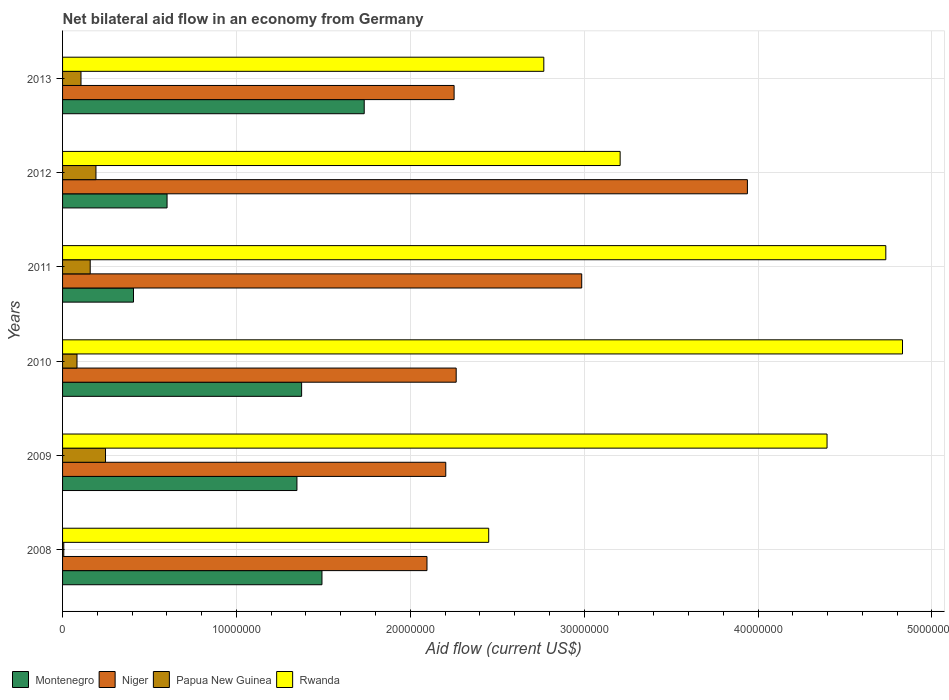How many different coloured bars are there?
Your answer should be compact. 4. Are the number of bars per tick equal to the number of legend labels?
Offer a terse response. Yes. How many bars are there on the 5th tick from the top?
Keep it short and to the point. 4. What is the label of the 6th group of bars from the top?
Make the answer very short. 2008. In how many cases, is the number of bars for a given year not equal to the number of legend labels?
Your answer should be compact. 0. What is the net bilateral aid flow in Niger in 2010?
Your answer should be very brief. 2.26e+07. Across all years, what is the maximum net bilateral aid flow in Papua New Guinea?
Provide a succinct answer. 2.47e+06. In which year was the net bilateral aid flow in Montenegro maximum?
Your answer should be very brief. 2013. In which year was the net bilateral aid flow in Niger minimum?
Make the answer very short. 2008. What is the total net bilateral aid flow in Niger in the graph?
Your answer should be compact. 1.57e+08. What is the difference between the net bilateral aid flow in Montenegro in 2008 and that in 2011?
Ensure brevity in your answer.  1.08e+07. What is the difference between the net bilateral aid flow in Montenegro in 2011 and the net bilateral aid flow in Papua New Guinea in 2008?
Your response must be concise. 4.01e+06. What is the average net bilateral aid flow in Niger per year?
Make the answer very short. 2.62e+07. In the year 2009, what is the difference between the net bilateral aid flow in Rwanda and net bilateral aid flow in Papua New Guinea?
Offer a terse response. 4.15e+07. In how many years, is the net bilateral aid flow in Papua New Guinea greater than 32000000 US$?
Your response must be concise. 0. What is the ratio of the net bilateral aid flow in Rwanda in 2008 to that in 2013?
Your response must be concise. 0.89. Is the net bilateral aid flow in Niger in 2011 less than that in 2012?
Your answer should be very brief. Yes. What is the difference between the highest and the second highest net bilateral aid flow in Niger?
Your answer should be compact. 9.53e+06. What is the difference between the highest and the lowest net bilateral aid flow in Rwanda?
Your response must be concise. 2.38e+07. What does the 2nd bar from the top in 2012 represents?
Your response must be concise. Papua New Guinea. What does the 3rd bar from the bottom in 2013 represents?
Offer a very short reply. Papua New Guinea. How many bars are there?
Give a very brief answer. 24. Are all the bars in the graph horizontal?
Ensure brevity in your answer.  Yes. How many years are there in the graph?
Ensure brevity in your answer.  6. Does the graph contain any zero values?
Provide a short and direct response. No. How many legend labels are there?
Make the answer very short. 4. What is the title of the graph?
Your answer should be compact. Net bilateral aid flow in an economy from Germany. What is the Aid flow (current US$) of Montenegro in 2008?
Offer a terse response. 1.49e+07. What is the Aid flow (current US$) in Niger in 2008?
Your answer should be compact. 2.10e+07. What is the Aid flow (current US$) in Papua New Guinea in 2008?
Provide a succinct answer. 7.00e+04. What is the Aid flow (current US$) of Rwanda in 2008?
Provide a succinct answer. 2.45e+07. What is the Aid flow (current US$) in Montenegro in 2009?
Your response must be concise. 1.35e+07. What is the Aid flow (current US$) of Niger in 2009?
Keep it short and to the point. 2.20e+07. What is the Aid flow (current US$) of Papua New Guinea in 2009?
Make the answer very short. 2.47e+06. What is the Aid flow (current US$) in Rwanda in 2009?
Your answer should be compact. 4.40e+07. What is the Aid flow (current US$) of Montenegro in 2010?
Offer a very short reply. 1.38e+07. What is the Aid flow (current US$) of Niger in 2010?
Offer a very short reply. 2.26e+07. What is the Aid flow (current US$) of Papua New Guinea in 2010?
Keep it short and to the point. 8.30e+05. What is the Aid flow (current US$) in Rwanda in 2010?
Give a very brief answer. 4.83e+07. What is the Aid flow (current US$) in Montenegro in 2011?
Offer a very short reply. 4.08e+06. What is the Aid flow (current US$) of Niger in 2011?
Your response must be concise. 2.99e+07. What is the Aid flow (current US$) in Papua New Guinea in 2011?
Give a very brief answer. 1.59e+06. What is the Aid flow (current US$) of Rwanda in 2011?
Keep it short and to the point. 4.74e+07. What is the Aid flow (current US$) in Montenegro in 2012?
Provide a short and direct response. 6.01e+06. What is the Aid flow (current US$) in Niger in 2012?
Ensure brevity in your answer.  3.94e+07. What is the Aid flow (current US$) in Papua New Guinea in 2012?
Offer a very short reply. 1.92e+06. What is the Aid flow (current US$) of Rwanda in 2012?
Give a very brief answer. 3.21e+07. What is the Aid flow (current US$) of Montenegro in 2013?
Provide a short and direct response. 1.74e+07. What is the Aid flow (current US$) of Niger in 2013?
Keep it short and to the point. 2.25e+07. What is the Aid flow (current US$) in Papua New Guinea in 2013?
Your answer should be compact. 1.06e+06. What is the Aid flow (current US$) of Rwanda in 2013?
Keep it short and to the point. 2.77e+07. Across all years, what is the maximum Aid flow (current US$) of Montenegro?
Give a very brief answer. 1.74e+07. Across all years, what is the maximum Aid flow (current US$) of Niger?
Offer a very short reply. 3.94e+07. Across all years, what is the maximum Aid flow (current US$) in Papua New Guinea?
Your answer should be very brief. 2.47e+06. Across all years, what is the maximum Aid flow (current US$) of Rwanda?
Your answer should be very brief. 4.83e+07. Across all years, what is the minimum Aid flow (current US$) of Montenegro?
Keep it short and to the point. 4.08e+06. Across all years, what is the minimum Aid flow (current US$) in Niger?
Your answer should be compact. 2.10e+07. Across all years, what is the minimum Aid flow (current US$) in Papua New Guinea?
Make the answer very short. 7.00e+04. Across all years, what is the minimum Aid flow (current US$) of Rwanda?
Give a very brief answer. 2.45e+07. What is the total Aid flow (current US$) in Montenegro in the graph?
Provide a succinct answer. 6.96e+07. What is the total Aid flow (current US$) in Niger in the graph?
Offer a terse response. 1.57e+08. What is the total Aid flow (current US$) of Papua New Guinea in the graph?
Your response must be concise. 7.94e+06. What is the total Aid flow (current US$) in Rwanda in the graph?
Your response must be concise. 2.24e+08. What is the difference between the Aid flow (current US$) of Montenegro in 2008 and that in 2009?
Provide a short and direct response. 1.44e+06. What is the difference between the Aid flow (current US$) of Niger in 2008 and that in 2009?
Give a very brief answer. -1.08e+06. What is the difference between the Aid flow (current US$) of Papua New Guinea in 2008 and that in 2009?
Your response must be concise. -2.40e+06. What is the difference between the Aid flow (current US$) of Rwanda in 2008 and that in 2009?
Offer a terse response. -1.95e+07. What is the difference between the Aid flow (current US$) of Montenegro in 2008 and that in 2010?
Ensure brevity in your answer.  1.17e+06. What is the difference between the Aid flow (current US$) in Niger in 2008 and that in 2010?
Keep it short and to the point. -1.68e+06. What is the difference between the Aid flow (current US$) of Papua New Guinea in 2008 and that in 2010?
Give a very brief answer. -7.60e+05. What is the difference between the Aid flow (current US$) in Rwanda in 2008 and that in 2010?
Keep it short and to the point. -2.38e+07. What is the difference between the Aid flow (current US$) in Montenegro in 2008 and that in 2011?
Ensure brevity in your answer.  1.08e+07. What is the difference between the Aid flow (current US$) of Niger in 2008 and that in 2011?
Ensure brevity in your answer.  -8.90e+06. What is the difference between the Aid flow (current US$) of Papua New Guinea in 2008 and that in 2011?
Give a very brief answer. -1.52e+06. What is the difference between the Aid flow (current US$) of Rwanda in 2008 and that in 2011?
Your answer should be very brief. -2.28e+07. What is the difference between the Aid flow (current US$) of Montenegro in 2008 and that in 2012?
Your response must be concise. 8.91e+06. What is the difference between the Aid flow (current US$) in Niger in 2008 and that in 2012?
Your response must be concise. -1.84e+07. What is the difference between the Aid flow (current US$) in Papua New Guinea in 2008 and that in 2012?
Provide a succinct answer. -1.85e+06. What is the difference between the Aid flow (current US$) in Rwanda in 2008 and that in 2012?
Your response must be concise. -7.56e+06. What is the difference between the Aid flow (current US$) of Montenegro in 2008 and that in 2013?
Give a very brief answer. -2.43e+06. What is the difference between the Aid flow (current US$) of Niger in 2008 and that in 2013?
Your answer should be very brief. -1.56e+06. What is the difference between the Aid flow (current US$) in Papua New Guinea in 2008 and that in 2013?
Offer a very short reply. -9.90e+05. What is the difference between the Aid flow (current US$) in Rwanda in 2008 and that in 2013?
Keep it short and to the point. -3.17e+06. What is the difference between the Aid flow (current US$) in Niger in 2009 and that in 2010?
Offer a terse response. -6.00e+05. What is the difference between the Aid flow (current US$) in Papua New Guinea in 2009 and that in 2010?
Your answer should be very brief. 1.64e+06. What is the difference between the Aid flow (current US$) in Rwanda in 2009 and that in 2010?
Keep it short and to the point. -4.34e+06. What is the difference between the Aid flow (current US$) in Montenegro in 2009 and that in 2011?
Give a very brief answer. 9.40e+06. What is the difference between the Aid flow (current US$) in Niger in 2009 and that in 2011?
Provide a short and direct response. -7.82e+06. What is the difference between the Aid flow (current US$) in Papua New Guinea in 2009 and that in 2011?
Make the answer very short. 8.80e+05. What is the difference between the Aid flow (current US$) of Rwanda in 2009 and that in 2011?
Keep it short and to the point. -3.38e+06. What is the difference between the Aid flow (current US$) of Montenegro in 2009 and that in 2012?
Provide a short and direct response. 7.47e+06. What is the difference between the Aid flow (current US$) in Niger in 2009 and that in 2012?
Your answer should be very brief. -1.74e+07. What is the difference between the Aid flow (current US$) in Papua New Guinea in 2009 and that in 2012?
Ensure brevity in your answer.  5.50e+05. What is the difference between the Aid flow (current US$) in Rwanda in 2009 and that in 2012?
Offer a very short reply. 1.19e+07. What is the difference between the Aid flow (current US$) of Montenegro in 2009 and that in 2013?
Ensure brevity in your answer.  -3.87e+06. What is the difference between the Aid flow (current US$) of Niger in 2009 and that in 2013?
Keep it short and to the point. -4.80e+05. What is the difference between the Aid flow (current US$) of Papua New Guinea in 2009 and that in 2013?
Your answer should be compact. 1.41e+06. What is the difference between the Aid flow (current US$) in Rwanda in 2009 and that in 2013?
Offer a terse response. 1.63e+07. What is the difference between the Aid flow (current US$) of Montenegro in 2010 and that in 2011?
Make the answer very short. 9.67e+06. What is the difference between the Aid flow (current US$) in Niger in 2010 and that in 2011?
Make the answer very short. -7.22e+06. What is the difference between the Aid flow (current US$) of Papua New Guinea in 2010 and that in 2011?
Your answer should be compact. -7.60e+05. What is the difference between the Aid flow (current US$) of Rwanda in 2010 and that in 2011?
Your response must be concise. 9.60e+05. What is the difference between the Aid flow (current US$) in Montenegro in 2010 and that in 2012?
Your answer should be very brief. 7.74e+06. What is the difference between the Aid flow (current US$) of Niger in 2010 and that in 2012?
Provide a short and direct response. -1.68e+07. What is the difference between the Aid flow (current US$) of Papua New Guinea in 2010 and that in 2012?
Ensure brevity in your answer.  -1.09e+06. What is the difference between the Aid flow (current US$) of Rwanda in 2010 and that in 2012?
Provide a succinct answer. 1.62e+07. What is the difference between the Aid flow (current US$) in Montenegro in 2010 and that in 2013?
Make the answer very short. -3.60e+06. What is the difference between the Aid flow (current US$) in Niger in 2010 and that in 2013?
Give a very brief answer. 1.20e+05. What is the difference between the Aid flow (current US$) of Papua New Guinea in 2010 and that in 2013?
Make the answer very short. -2.30e+05. What is the difference between the Aid flow (current US$) in Rwanda in 2010 and that in 2013?
Your answer should be compact. 2.06e+07. What is the difference between the Aid flow (current US$) in Montenegro in 2011 and that in 2012?
Ensure brevity in your answer.  -1.93e+06. What is the difference between the Aid flow (current US$) in Niger in 2011 and that in 2012?
Give a very brief answer. -9.53e+06. What is the difference between the Aid flow (current US$) of Papua New Guinea in 2011 and that in 2012?
Your answer should be compact. -3.30e+05. What is the difference between the Aid flow (current US$) of Rwanda in 2011 and that in 2012?
Your answer should be compact. 1.53e+07. What is the difference between the Aid flow (current US$) in Montenegro in 2011 and that in 2013?
Offer a very short reply. -1.33e+07. What is the difference between the Aid flow (current US$) of Niger in 2011 and that in 2013?
Offer a terse response. 7.34e+06. What is the difference between the Aid flow (current US$) of Papua New Guinea in 2011 and that in 2013?
Provide a succinct answer. 5.30e+05. What is the difference between the Aid flow (current US$) of Rwanda in 2011 and that in 2013?
Provide a short and direct response. 1.97e+07. What is the difference between the Aid flow (current US$) in Montenegro in 2012 and that in 2013?
Your answer should be very brief. -1.13e+07. What is the difference between the Aid flow (current US$) of Niger in 2012 and that in 2013?
Offer a very short reply. 1.69e+07. What is the difference between the Aid flow (current US$) in Papua New Guinea in 2012 and that in 2013?
Give a very brief answer. 8.60e+05. What is the difference between the Aid flow (current US$) of Rwanda in 2012 and that in 2013?
Your answer should be compact. 4.39e+06. What is the difference between the Aid flow (current US$) of Montenegro in 2008 and the Aid flow (current US$) of Niger in 2009?
Provide a succinct answer. -7.12e+06. What is the difference between the Aid flow (current US$) in Montenegro in 2008 and the Aid flow (current US$) in Papua New Guinea in 2009?
Your response must be concise. 1.24e+07. What is the difference between the Aid flow (current US$) of Montenegro in 2008 and the Aid flow (current US$) of Rwanda in 2009?
Provide a short and direct response. -2.90e+07. What is the difference between the Aid flow (current US$) of Niger in 2008 and the Aid flow (current US$) of Papua New Guinea in 2009?
Provide a succinct answer. 1.85e+07. What is the difference between the Aid flow (current US$) of Niger in 2008 and the Aid flow (current US$) of Rwanda in 2009?
Make the answer very short. -2.30e+07. What is the difference between the Aid flow (current US$) of Papua New Guinea in 2008 and the Aid flow (current US$) of Rwanda in 2009?
Your response must be concise. -4.39e+07. What is the difference between the Aid flow (current US$) of Montenegro in 2008 and the Aid flow (current US$) of Niger in 2010?
Your answer should be very brief. -7.72e+06. What is the difference between the Aid flow (current US$) in Montenegro in 2008 and the Aid flow (current US$) in Papua New Guinea in 2010?
Offer a terse response. 1.41e+07. What is the difference between the Aid flow (current US$) of Montenegro in 2008 and the Aid flow (current US$) of Rwanda in 2010?
Offer a very short reply. -3.34e+07. What is the difference between the Aid flow (current US$) in Niger in 2008 and the Aid flow (current US$) in Papua New Guinea in 2010?
Provide a succinct answer. 2.01e+07. What is the difference between the Aid flow (current US$) in Niger in 2008 and the Aid flow (current US$) in Rwanda in 2010?
Provide a short and direct response. -2.74e+07. What is the difference between the Aid flow (current US$) of Papua New Guinea in 2008 and the Aid flow (current US$) of Rwanda in 2010?
Provide a succinct answer. -4.82e+07. What is the difference between the Aid flow (current US$) in Montenegro in 2008 and the Aid flow (current US$) in Niger in 2011?
Provide a succinct answer. -1.49e+07. What is the difference between the Aid flow (current US$) in Montenegro in 2008 and the Aid flow (current US$) in Papua New Guinea in 2011?
Your answer should be very brief. 1.33e+07. What is the difference between the Aid flow (current US$) in Montenegro in 2008 and the Aid flow (current US$) in Rwanda in 2011?
Provide a succinct answer. -3.24e+07. What is the difference between the Aid flow (current US$) of Niger in 2008 and the Aid flow (current US$) of Papua New Guinea in 2011?
Make the answer very short. 1.94e+07. What is the difference between the Aid flow (current US$) of Niger in 2008 and the Aid flow (current US$) of Rwanda in 2011?
Provide a short and direct response. -2.64e+07. What is the difference between the Aid flow (current US$) of Papua New Guinea in 2008 and the Aid flow (current US$) of Rwanda in 2011?
Give a very brief answer. -4.73e+07. What is the difference between the Aid flow (current US$) in Montenegro in 2008 and the Aid flow (current US$) in Niger in 2012?
Keep it short and to the point. -2.45e+07. What is the difference between the Aid flow (current US$) of Montenegro in 2008 and the Aid flow (current US$) of Papua New Guinea in 2012?
Ensure brevity in your answer.  1.30e+07. What is the difference between the Aid flow (current US$) of Montenegro in 2008 and the Aid flow (current US$) of Rwanda in 2012?
Offer a very short reply. -1.72e+07. What is the difference between the Aid flow (current US$) of Niger in 2008 and the Aid flow (current US$) of Papua New Guinea in 2012?
Give a very brief answer. 1.90e+07. What is the difference between the Aid flow (current US$) of Niger in 2008 and the Aid flow (current US$) of Rwanda in 2012?
Offer a terse response. -1.11e+07. What is the difference between the Aid flow (current US$) of Papua New Guinea in 2008 and the Aid flow (current US$) of Rwanda in 2012?
Offer a terse response. -3.20e+07. What is the difference between the Aid flow (current US$) in Montenegro in 2008 and the Aid flow (current US$) in Niger in 2013?
Your answer should be compact. -7.60e+06. What is the difference between the Aid flow (current US$) in Montenegro in 2008 and the Aid flow (current US$) in Papua New Guinea in 2013?
Your response must be concise. 1.39e+07. What is the difference between the Aid flow (current US$) of Montenegro in 2008 and the Aid flow (current US$) of Rwanda in 2013?
Ensure brevity in your answer.  -1.28e+07. What is the difference between the Aid flow (current US$) in Niger in 2008 and the Aid flow (current US$) in Papua New Guinea in 2013?
Make the answer very short. 1.99e+07. What is the difference between the Aid flow (current US$) of Niger in 2008 and the Aid flow (current US$) of Rwanda in 2013?
Give a very brief answer. -6.72e+06. What is the difference between the Aid flow (current US$) of Papua New Guinea in 2008 and the Aid flow (current US$) of Rwanda in 2013?
Keep it short and to the point. -2.76e+07. What is the difference between the Aid flow (current US$) of Montenegro in 2009 and the Aid flow (current US$) of Niger in 2010?
Make the answer very short. -9.16e+06. What is the difference between the Aid flow (current US$) in Montenegro in 2009 and the Aid flow (current US$) in Papua New Guinea in 2010?
Give a very brief answer. 1.26e+07. What is the difference between the Aid flow (current US$) in Montenegro in 2009 and the Aid flow (current US$) in Rwanda in 2010?
Offer a terse response. -3.48e+07. What is the difference between the Aid flow (current US$) in Niger in 2009 and the Aid flow (current US$) in Papua New Guinea in 2010?
Keep it short and to the point. 2.12e+07. What is the difference between the Aid flow (current US$) of Niger in 2009 and the Aid flow (current US$) of Rwanda in 2010?
Ensure brevity in your answer.  -2.63e+07. What is the difference between the Aid flow (current US$) of Papua New Guinea in 2009 and the Aid flow (current US$) of Rwanda in 2010?
Offer a very short reply. -4.58e+07. What is the difference between the Aid flow (current US$) in Montenegro in 2009 and the Aid flow (current US$) in Niger in 2011?
Offer a very short reply. -1.64e+07. What is the difference between the Aid flow (current US$) in Montenegro in 2009 and the Aid flow (current US$) in Papua New Guinea in 2011?
Give a very brief answer. 1.19e+07. What is the difference between the Aid flow (current US$) of Montenegro in 2009 and the Aid flow (current US$) of Rwanda in 2011?
Your answer should be compact. -3.39e+07. What is the difference between the Aid flow (current US$) in Niger in 2009 and the Aid flow (current US$) in Papua New Guinea in 2011?
Your answer should be very brief. 2.04e+07. What is the difference between the Aid flow (current US$) of Niger in 2009 and the Aid flow (current US$) of Rwanda in 2011?
Your answer should be very brief. -2.53e+07. What is the difference between the Aid flow (current US$) of Papua New Guinea in 2009 and the Aid flow (current US$) of Rwanda in 2011?
Keep it short and to the point. -4.49e+07. What is the difference between the Aid flow (current US$) of Montenegro in 2009 and the Aid flow (current US$) of Niger in 2012?
Your answer should be compact. -2.59e+07. What is the difference between the Aid flow (current US$) of Montenegro in 2009 and the Aid flow (current US$) of Papua New Guinea in 2012?
Your answer should be compact. 1.16e+07. What is the difference between the Aid flow (current US$) in Montenegro in 2009 and the Aid flow (current US$) in Rwanda in 2012?
Your answer should be very brief. -1.86e+07. What is the difference between the Aid flow (current US$) of Niger in 2009 and the Aid flow (current US$) of Papua New Guinea in 2012?
Offer a terse response. 2.01e+07. What is the difference between the Aid flow (current US$) of Niger in 2009 and the Aid flow (current US$) of Rwanda in 2012?
Keep it short and to the point. -1.00e+07. What is the difference between the Aid flow (current US$) of Papua New Guinea in 2009 and the Aid flow (current US$) of Rwanda in 2012?
Your answer should be compact. -2.96e+07. What is the difference between the Aid flow (current US$) in Montenegro in 2009 and the Aid flow (current US$) in Niger in 2013?
Your answer should be very brief. -9.04e+06. What is the difference between the Aid flow (current US$) in Montenegro in 2009 and the Aid flow (current US$) in Papua New Guinea in 2013?
Offer a terse response. 1.24e+07. What is the difference between the Aid flow (current US$) of Montenegro in 2009 and the Aid flow (current US$) of Rwanda in 2013?
Offer a terse response. -1.42e+07. What is the difference between the Aid flow (current US$) of Niger in 2009 and the Aid flow (current US$) of Papua New Guinea in 2013?
Offer a very short reply. 2.10e+07. What is the difference between the Aid flow (current US$) of Niger in 2009 and the Aid flow (current US$) of Rwanda in 2013?
Ensure brevity in your answer.  -5.64e+06. What is the difference between the Aid flow (current US$) of Papua New Guinea in 2009 and the Aid flow (current US$) of Rwanda in 2013?
Provide a short and direct response. -2.52e+07. What is the difference between the Aid flow (current US$) of Montenegro in 2010 and the Aid flow (current US$) of Niger in 2011?
Your response must be concise. -1.61e+07. What is the difference between the Aid flow (current US$) of Montenegro in 2010 and the Aid flow (current US$) of Papua New Guinea in 2011?
Your answer should be compact. 1.22e+07. What is the difference between the Aid flow (current US$) in Montenegro in 2010 and the Aid flow (current US$) in Rwanda in 2011?
Your response must be concise. -3.36e+07. What is the difference between the Aid flow (current US$) in Niger in 2010 and the Aid flow (current US$) in Papua New Guinea in 2011?
Keep it short and to the point. 2.10e+07. What is the difference between the Aid flow (current US$) in Niger in 2010 and the Aid flow (current US$) in Rwanda in 2011?
Give a very brief answer. -2.47e+07. What is the difference between the Aid flow (current US$) of Papua New Guinea in 2010 and the Aid flow (current US$) of Rwanda in 2011?
Provide a short and direct response. -4.65e+07. What is the difference between the Aid flow (current US$) of Montenegro in 2010 and the Aid flow (current US$) of Niger in 2012?
Give a very brief answer. -2.56e+07. What is the difference between the Aid flow (current US$) of Montenegro in 2010 and the Aid flow (current US$) of Papua New Guinea in 2012?
Offer a terse response. 1.18e+07. What is the difference between the Aid flow (current US$) of Montenegro in 2010 and the Aid flow (current US$) of Rwanda in 2012?
Provide a short and direct response. -1.83e+07. What is the difference between the Aid flow (current US$) of Niger in 2010 and the Aid flow (current US$) of Papua New Guinea in 2012?
Your answer should be compact. 2.07e+07. What is the difference between the Aid flow (current US$) of Niger in 2010 and the Aid flow (current US$) of Rwanda in 2012?
Provide a short and direct response. -9.43e+06. What is the difference between the Aid flow (current US$) of Papua New Guinea in 2010 and the Aid flow (current US$) of Rwanda in 2012?
Make the answer very short. -3.12e+07. What is the difference between the Aid flow (current US$) of Montenegro in 2010 and the Aid flow (current US$) of Niger in 2013?
Make the answer very short. -8.77e+06. What is the difference between the Aid flow (current US$) of Montenegro in 2010 and the Aid flow (current US$) of Papua New Guinea in 2013?
Provide a succinct answer. 1.27e+07. What is the difference between the Aid flow (current US$) in Montenegro in 2010 and the Aid flow (current US$) in Rwanda in 2013?
Make the answer very short. -1.39e+07. What is the difference between the Aid flow (current US$) in Niger in 2010 and the Aid flow (current US$) in Papua New Guinea in 2013?
Your answer should be very brief. 2.16e+07. What is the difference between the Aid flow (current US$) of Niger in 2010 and the Aid flow (current US$) of Rwanda in 2013?
Provide a short and direct response. -5.04e+06. What is the difference between the Aid flow (current US$) of Papua New Guinea in 2010 and the Aid flow (current US$) of Rwanda in 2013?
Offer a very short reply. -2.68e+07. What is the difference between the Aid flow (current US$) in Montenegro in 2011 and the Aid flow (current US$) in Niger in 2012?
Offer a very short reply. -3.53e+07. What is the difference between the Aid flow (current US$) in Montenegro in 2011 and the Aid flow (current US$) in Papua New Guinea in 2012?
Your answer should be very brief. 2.16e+06. What is the difference between the Aid flow (current US$) of Montenegro in 2011 and the Aid flow (current US$) of Rwanda in 2012?
Keep it short and to the point. -2.80e+07. What is the difference between the Aid flow (current US$) of Niger in 2011 and the Aid flow (current US$) of Papua New Guinea in 2012?
Your response must be concise. 2.79e+07. What is the difference between the Aid flow (current US$) in Niger in 2011 and the Aid flow (current US$) in Rwanda in 2012?
Give a very brief answer. -2.21e+06. What is the difference between the Aid flow (current US$) of Papua New Guinea in 2011 and the Aid flow (current US$) of Rwanda in 2012?
Your answer should be compact. -3.05e+07. What is the difference between the Aid flow (current US$) of Montenegro in 2011 and the Aid flow (current US$) of Niger in 2013?
Ensure brevity in your answer.  -1.84e+07. What is the difference between the Aid flow (current US$) of Montenegro in 2011 and the Aid flow (current US$) of Papua New Guinea in 2013?
Keep it short and to the point. 3.02e+06. What is the difference between the Aid flow (current US$) of Montenegro in 2011 and the Aid flow (current US$) of Rwanda in 2013?
Your answer should be very brief. -2.36e+07. What is the difference between the Aid flow (current US$) in Niger in 2011 and the Aid flow (current US$) in Papua New Guinea in 2013?
Your answer should be very brief. 2.88e+07. What is the difference between the Aid flow (current US$) in Niger in 2011 and the Aid flow (current US$) in Rwanda in 2013?
Give a very brief answer. 2.18e+06. What is the difference between the Aid flow (current US$) in Papua New Guinea in 2011 and the Aid flow (current US$) in Rwanda in 2013?
Offer a very short reply. -2.61e+07. What is the difference between the Aid flow (current US$) of Montenegro in 2012 and the Aid flow (current US$) of Niger in 2013?
Keep it short and to the point. -1.65e+07. What is the difference between the Aid flow (current US$) in Montenegro in 2012 and the Aid flow (current US$) in Papua New Guinea in 2013?
Provide a short and direct response. 4.95e+06. What is the difference between the Aid flow (current US$) in Montenegro in 2012 and the Aid flow (current US$) in Rwanda in 2013?
Your response must be concise. -2.17e+07. What is the difference between the Aid flow (current US$) in Niger in 2012 and the Aid flow (current US$) in Papua New Guinea in 2013?
Your answer should be very brief. 3.83e+07. What is the difference between the Aid flow (current US$) in Niger in 2012 and the Aid flow (current US$) in Rwanda in 2013?
Keep it short and to the point. 1.17e+07. What is the difference between the Aid flow (current US$) in Papua New Guinea in 2012 and the Aid flow (current US$) in Rwanda in 2013?
Provide a succinct answer. -2.58e+07. What is the average Aid flow (current US$) of Montenegro per year?
Give a very brief answer. 1.16e+07. What is the average Aid flow (current US$) in Niger per year?
Offer a very short reply. 2.62e+07. What is the average Aid flow (current US$) in Papua New Guinea per year?
Ensure brevity in your answer.  1.32e+06. What is the average Aid flow (current US$) in Rwanda per year?
Give a very brief answer. 3.73e+07. In the year 2008, what is the difference between the Aid flow (current US$) of Montenegro and Aid flow (current US$) of Niger?
Keep it short and to the point. -6.04e+06. In the year 2008, what is the difference between the Aid flow (current US$) in Montenegro and Aid flow (current US$) in Papua New Guinea?
Keep it short and to the point. 1.48e+07. In the year 2008, what is the difference between the Aid flow (current US$) of Montenegro and Aid flow (current US$) of Rwanda?
Your answer should be very brief. -9.59e+06. In the year 2008, what is the difference between the Aid flow (current US$) of Niger and Aid flow (current US$) of Papua New Guinea?
Offer a very short reply. 2.09e+07. In the year 2008, what is the difference between the Aid flow (current US$) in Niger and Aid flow (current US$) in Rwanda?
Your answer should be very brief. -3.55e+06. In the year 2008, what is the difference between the Aid flow (current US$) of Papua New Guinea and Aid flow (current US$) of Rwanda?
Your response must be concise. -2.44e+07. In the year 2009, what is the difference between the Aid flow (current US$) in Montenegro and Aid flow (current US$) in Niger?
Your answer should be very brief. -8.56e+06. In the year 2009, what is the difference between the Aid flow (current US$) of Montenegro and Aid flow (current US$) of Papua New Guinea?
Your response must be concise. 1.10e+07. In the year 2009, what is the difference between the Aid flow (current US$) of Montenegro and Aid flow (current US$) of Rwanda?
Make the answer very short. -3.05e+07. In the year 2009, what is the difference between the Aid flow (current US$) of Niger and Aid flow (current US$) of Papua New Guinea?
Ensure brevity in your answer.  1.96e+07. In the year 2009, what is the difference between the Aid flow (current US$) in Niger and Aid flow (current US$) in Rwanda?
Your answer should be compact. -2.19e+07. In the year 2009, what is the difference between the Aid flow (current US$) in Papua New Guinea and Aid flow (current US$) in Rwanda?
Offer a terse response. -4.15e+07. In the year 2010, what is the difference between the Aid flow (current US$) in Montenegro and Aid flow (current US$) in Niger?
Keep it short and to the point. -8.89e+06. In the year 2010, what is the difference between the Aid flow (current US$) in Montenegro and Aid flow (current US$) in Papua New Guinea?
Ensure brevity in your answer.  1.29e+07. In the year 2010, what is the difference between the Aid flow (current US$) of Montenegro and Aid flow (current US$) of Rwanda?
Ensure brevity in your answer.  -3.46e+07. In the year 2010, what is the difference between the Aid flow (current US$) of Niger and Aid flow (current US$) of Papua New Guinea?
Keep it short and to the point. 2.18e+07. In the year 2010, what is the difference between the Aid flow (current US$) of Niger and Aid flow (current US$) of Rwanda?
Your answer should be compact. -2.57e+07. In the year 2010, what is the difference between the Aid flow (current US$) in Papua New Guinea and Aid flow (current US$) in Rwanda?
Provide a short and direct response. -4.75e+07. In the year 2011, what is the difference between the Aid flow (current US$) in Montenegro and Aid flow (current US$) in Niger?
Make the answer very short. -2.58e+07. In the year 2011, what is the difference between the Aid flow (current US$) in Montenegro and Aid flow (current US$) in Papua New Guinea?
Offer a very short reply. 2.49e+06. In the year 2011, what is the difference between the Aid flow (current US$) in Montenegro and Aid flow (current US$) in Rwanda?
Provide a short and direct response. -4.33e+07. In the year 2011, what is the difference between the Aid flow (current US$) of Niger and Aid flow (current US$) of Papua New Guinea?
Give a very brief answer. 2.83e+07. In the year 2011, what is the difference between the Aid flow (current US$) of Niger and Aid flow (current US$) of Rwanda?
Your response must be concise. -1.75e+07. In the year 2011, what is the difference between the Aid flow (current US$) of Papua New Guinea and Aid flow (current US$) of Rwanda?
Your answer should be compact. -4.58e+07. In the year 2012, what is the difference between the Aid flow (current US$) of Montenegro and Aid flow (current US$) of Niger?
Provide a short and direct response. -3.34e+07. In the year 2012, what is the difference between the Aid flow (current US$) in Montenegro and Aid flow (current US$) in Papua New Guinea?
Your answer should be compact. 4.09e+06. In the year 2012, what is the difference between the Aid flow (current US$) of Montenegro and Aid flow (current US$) of Rwanda?
Keep it short and to the point. -2.61e+07. In the year 2012, what is the difference between the Aid flow (current US$) of Niger and Aid flow (current US$) of Papua New Guinea?
Give a very brief answer. 3.75e+07. In the year 2012, what is the difference between the Aid flow (current US$) in Niger and Aid flow (current US$) in Rwanda?
Offer a very short reply. 7.32e+06. In the year 2012, what is the difference between the Aid flow (current US$) of Papua New Guinea and Aid flow (current US$) of Rwanda?
Keep it short and to the point. -3.02e+07. In the year 2013, what is the difference between the Aid flow (current US$) in Montenegro and Aid flow (current US$) in Niger?
Make the answer very short. -5.17e+06. In the year 2013, what is the difference between the Aid flow (current US$) of Montenegro and Aid flow (current US$) of Papua New Guinea?
Give a very brief answer. 1.63e+07. In the year 2013, what is the difference between the Aid flow (current US$) in Montenegro and Aid flow (current US$) in Rwanda?
Your response must be concise. -1.03e+07. In the year 2013, what is the difference between the Aid flow (current US$) of Niger and Aid flow (current US$) of Papua New Guinea?
Your answer should be compact. 2.15e+07. In the year 2013, what is the difference between the Aid flow (current US$) in Niger and Aid flow (current US$) in Rwanda?
Provide a succinct answer. -5.16e+06. In the year 2013, what is the difference between the Aid flow (current US$) in Papua New Guinea and Aid flow (current US$) in Rwanda?
Provide a succinct answer. -2.66e+07. What is the ratio of the Aid flow (current US$) in Montenegro in 2008 to that in 2009?
Offer a very short reply. 1.11. What is the ratio of the Aid flow (current US$) of Niger in 2008 to that in 2009?
Your response must be concise. 0.95. What is the ratio of the Aid flow (current US$) in Papua New Guinea in 2008 to that in 2009?
Your response must be concise. 0.03. What is the ratio of the Aid flow (current US$) in Rwanda in 2008 to that in 2009?
Ensure brevity in your answer.  0.56. What is the ratio of the Aid flow (current US$) in Montenegro in 2008 to that in 2010?
Make the answer very short. 1.09. What is the ratio of the Aid flow (current US$) in Niger in 2008 to that in 2010?
Provide a succinct answer. 0.93. What is the ratio of the Aid flow (current US$) in Papua New Guinea in 2008 to that in 2010?
Offer a terse response. 0.08. What is the ratio of the Aid flow (current US$) in Rwanda in 2008 to that in 2010?
Provide a succinct answer. 0.51. What is the ratio of the Aid flow (current US$) of Montenegro in 2008 to that in 2011?
Your answer should be compact. 3.66. What is the ratio of the Aid flow (current US$) in Niger in 2008 to that in 2011?
Offer a terse response. 0.7. What is the ratio of the Aid flow (current US$) in Papua New Guinea in 2008 to that in 2011?
Ensure brevity in your answer.  0.04. What is the ratio of the Aid flow (current US$) in Rwanda in 2008 to that in 2011?
Offer a terse response. 0.52. What is the ratio of the Aid flow (current US$) in Montenegro in 2008 to that in 2012?
Your response must be concise. 2.48. What is the ratio of the Aid flow (current US$) of Niger in 2008 to that in 2012?
Give a very brief answer. 0.53. What is the ratio of the Aid flow (current US$) of Papua New Guinea in 2008 to that in 2012?
Your response must be concise. 0.04. What is the ratio of the Aid flow (current US$) of Rwanda in 2008 to that in 2012?
Your answer should be very brief. 0.76. What is the ratio of the Aid flow (current US$) in Montenegro in 2008 to that in 2013?
Your response must be concise. 0.86. What is the ratio of the Aid flow (current US$) in Niger in 2008 to that in 2013?
Your response must be concise. 0.93. What is the ratio of the Aid flow (current US$) of Papua New Guinea in 2008 to that in 2013?
Give a very brief answer. 0.07. What is the ratio of the Aid flow (current US$) in Rwanda in 2008 to that in 2013?
Give a very brief answer. 0.89. What is the ratio of the Aid flow (current US$) in Montenegro in 2009 to that in 2010?
Your answer should be very brief. 0.98. What is the ratio of the Aid flow (current US$) of Niger in 2009 to that in 2010?
Ensure brevity in your answer.  0.97. What is the ratio of the Aid flow (current US$) in Papua New Guinea in 2009 to that in 2010?
Your answer should be very brief. 2.98. What is the ratio of the Aid flow (current US$) of Rwanda in 2009 to that in 2010?
Provide a succinct answer. 0.91. What is the ratio of the Aid flow (current US$) in Montenegro in 2009 to that in 2011?
Give a very brief answer. 3.3. What is the ratio of the Aid flow (current US$) in Niger in 2009 to that in 2011?
Make the answer very short. 0.74. What is the ratio of the Aid flow (current US$) of Papua New Guinea in 2009 to that in 2011?
Your answer should be compact. 1.55. What is the ratio of the Aid flow (current US$) of Montenegro in 2009 to that in 2012?
Make the answer very short. 2.24. What is the ratio of the Aid flow (current US$) of Niger in 2009 to that in 2012?
Your response must be concise. 0.56. What is the ratio of the Aid flow (current US$) of Papua New Guinea in 2009 to that in 2012?
Ensure brevity in your answer.  1.29. What is the ratio of the Aid flow (current US$) in Rwanda in 2009 to that in 2012?
Offer a very short reply. 1.37. What is the ratio of the Aid flow (current US$) of Montenegro in 2009 to that in 2013?
Offer a terse response. 0.78. What is the ratio of the Aid flow (current US$) in Niger in 2009 to that in 2013?
Your response must be concise. 0.98. What is the ratio of the Aid flow (current US$) in Papua New Guinea in 2009 to that in 2013?
Give a very brief answer. 2.33. What is the ratio of the Aid flow (current US$) in Rwanda in 2009 to that in 2013?
Make the answer very short. 1.59. What is the ratio of the Aid flow (current US$) of Montenegro in 2010 to that in 2011?
Offer a very short reply. 3.37. What is the ratio of the Aid flow (current US$) of Niger in 2010 to that in 2011?
Give a very brief answer. 0.76. What is the ratio of the Aid flow (current US$) of Papua New Guinea in 2010 to that in 2011?
Provide a short and direct response. 0.52. What is the ratio of the Aid flow (current US$) of Rwanda in 2010 to that in 2011?
Make the answer very short. 1.02. What is the ratio of the Aid flow (current US$) in Montenegro in 2010 to that in 2012?
Your answer should be very brief. 2.29. What is the ratio of the Aid flow (current US$) of Niger in 2010 to that in 2012?
Your response must be concise. 0.57. What is the ratio of the Aid flow (current US$) of Papua New Guinea in 2010 to that in 2012?
Offer a very short reply. 0.43. What is the ratio of the Aid flow (current US$) in Rwanda in 2010 to that in 2012?
Your answer should be very brief. 1.51. What is the ratio of the Aid flow (current US$) of Montenegro in 2010 to that in 2013?
Offer a very short reply. 0.79. What is the ratio of the Aid flow (current US$) of Papua New Guinea in 2010 to that in 2013?
Give a very brief answer. 0.78. What is the ratio of the Aid flow (current US$) in Rwanda in 2010 to that in 2013?
Make the answer very short. 1.75. What is the ratio of the Aid flow (current US$) in Montenegro in 2011 to that in 2012?
Offer a terse response. 0.68. What is the ratio of the Aid flow (current US$) of Niger in 2011 to that in 2012?
Offer a very short reply. 0.76. What is the ratio of the Aid flow (current US$) of Papua New Guinea in 2011 to that in 2012?
Your response must be concise. 0.83. What is the ratio of the Aid flow (current US$) in Rwanda in 2011 to that in 2012?
Offer a terse response. 1.48. What is the ratio of the Aid flow (current US$) of Montenegro in 2011 to that in 2013?
Your response must be concise. 0.24. What is the ratio of the Aid flow (current US$) of Niger in 2011 to that in 2013?
Provide a short and direct response. 1.33. What is the ratio of the Aid flow (current US$) of Rwanda in 2011 to that in 2013?
Provide a short and direct response. 1.71. What is the ratio of the Aid flow (current US$) in Montenegro in 2012 to that in 2013?
Keep it short and to the point. 0.35. What is the ratio of the Aid flow (current US$) in Niger in 2012 to that in 2013?
Ensure brevity in your answer.  1.75. What is the ratio of the Aid flow (current US$) in Papua New Guinea in 2012 to that in 2013?
Your response must be concise. 1.81. What is the ratio of the Aid flow (current US$) in Rwanda in 2012 to that in 2013?
Make the answer very short. 1.16. What is the difference between the highest and the second highest Aid flow (current US$) in Montenegro?
Keep it short and to the point. 2.43e+06. What is the difference between the highest and the second highest Aid flow (current US$) in Niger?
Keep it short and to the point. 9.53e+06. What is the difference between the highest and the second highest Aid flow (current US$) in Rwanda?
Ensure brevity in your answer.  9.60e+05. What is the difference between the highest and the lowest Aid flow (current US$) in Montenegro?
Give a very brief answer. 1.33e+07. What is the difference between the highest and the lowest Aid flow (current US$) of Niger?
Your answer should be very brief. 1.84e+07. What is the difference between the highest and the lowest Aid flow (current US$) in Papua New Guinea?
Keep it short and to the point. 2.40e+06. What is the difference between the highest and the lowest Aid flow (current US$) in Rwanda?
Ensure brevity in your answer.  2.38e+07. 